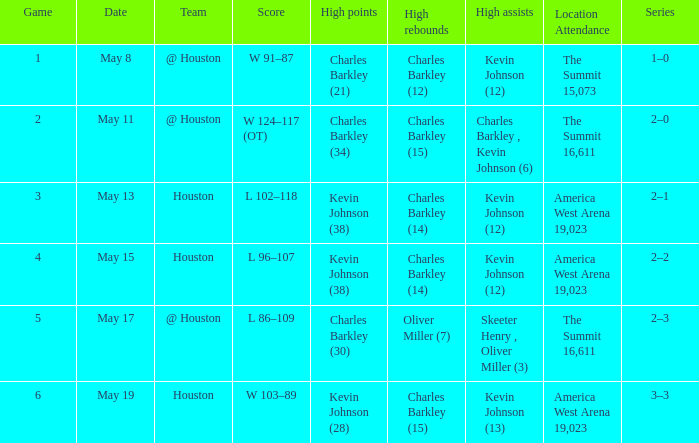What is the number of distinct high scores for the game on may 15th? 1.0. 